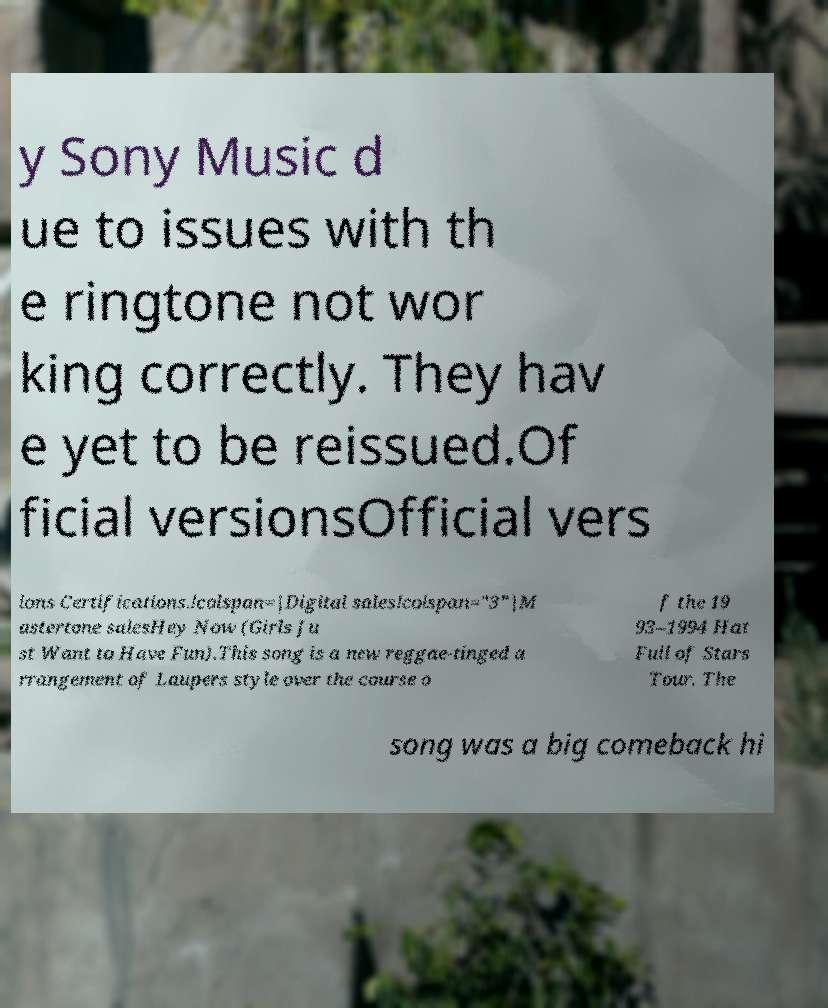Could you extract and type out the text from this image? y Sony Music d ue to issues with th e ringtone not wor king correctly. They hav e yet to be reissued.Of ficial versionsOfficial vers ions Certifications.!colspan=|Digital sales!colspan="3"|M astertone salesHey Now (Girls Ju st Want to Have Fun).This song is a new reggae-tinged a rrangement of Laupers style over the course o f the 19 93–1994 Hat Full of Stars Tour. The song was a big comeback hi 